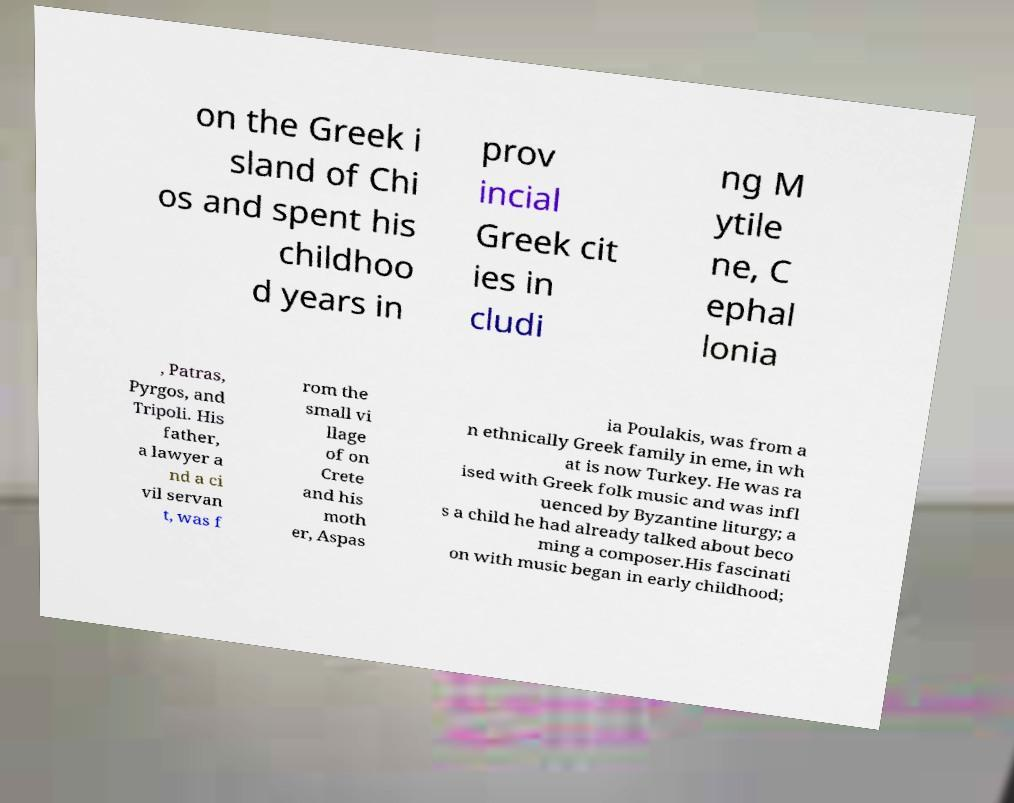Please identify and transcribe the text found in this image. on the Greek i sland of Chi os and spent his childhoo d years in prov incial Greek cit ies in cludi ng M ytile ne, C ephal lonia , Patras, Pyrgos, and Tripoli. His father, a lawyer a nd a ci vil servan t, was f rom the small vi llage of on Crete and his moth er, Aspas ia Poulakis, was from a n ethnically Greek family in eme, in wh at is now Turkey. He was ra ised with Greek folk music and was infl uenced by Byzantine liturgy; a s a child he had already talked about beco ming a composer.His fascinati on with music began in early childhood; 